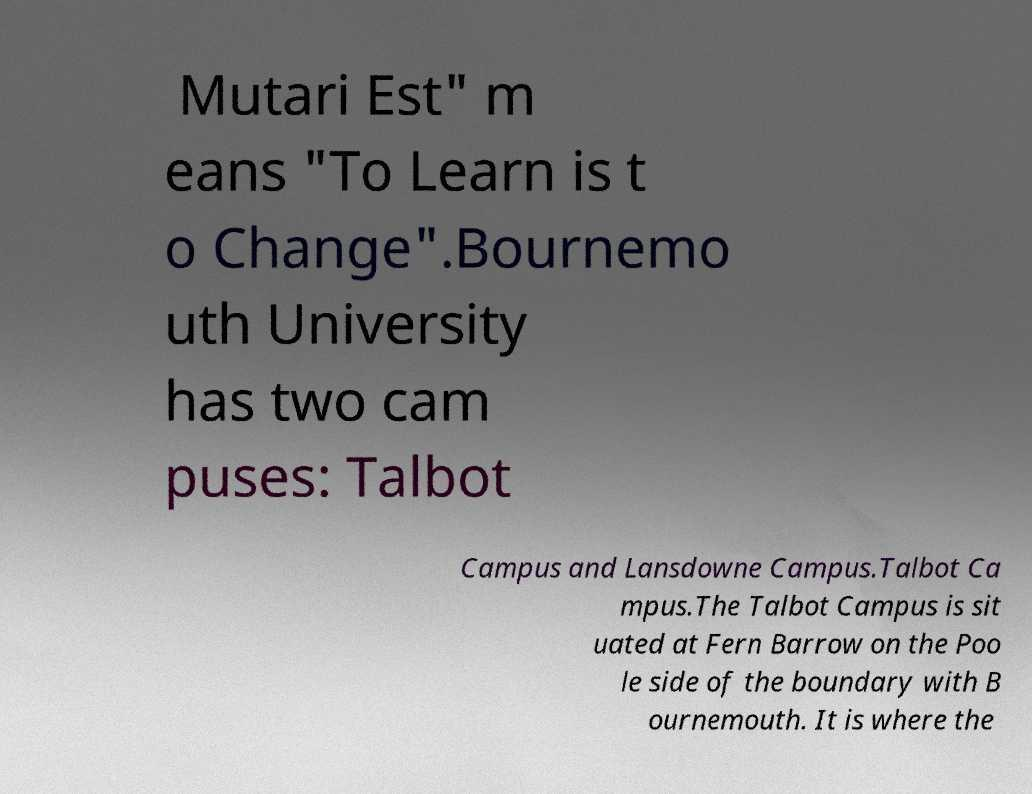Could you assist in decoding the text presented in this image and type it out clearly? Mutari Est" m eans "To Learn is t o Change".Bournemo uth University has two cam puses: Talbot Campus and Lansdowne Campus.Talbot Ca mpus.The Talbot Campus is sit uated at Fern Barrow on the Poo le side of the boundary with B ournemouth. It is where the 